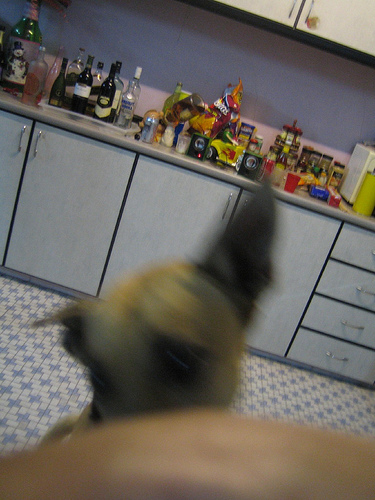<image>What bird is this? It is impossible to identify the bird without image. It can be parrot, chicken, cockatoo, or parakeet. What color bow is on the dog? There is no bow on the dog in the image. What color bow is on the dog? There is no bow on the dog. What bird is this? I don't know what bird it is. It can be seen 'parrot', 'chicken', 'cockatoo' or 'parakeet'. 